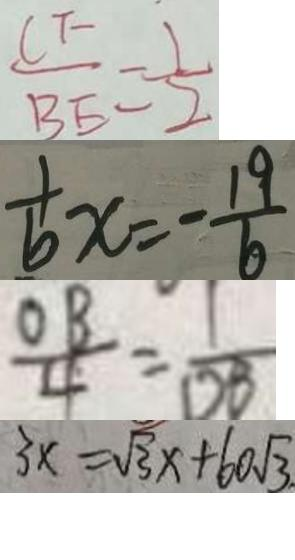<formula> <loc_0><loc_0><loc_500><loc_500>\frac { C F } { B E } = \frac { 1 } { 2 } 
 \frac { 1 } { 6 } x = - \frac { 1 9 } { 6 } 
 \frac { O B } { 4 } = \frac { 1 } { D B } 
 3 x = \sqrt { 3 } x + 6 0 \sqrt { 3 }</formula> 